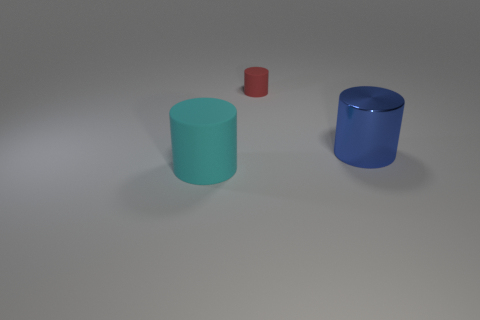What material is the cylinder right of the rubber cylinder behind the large object that is behind the large cyan thing?
Your answer should be compact. Metal. What number of purple matte cylinders are there?
Provide a succinct answer. 0. How many gray objects are big cylinders or tiny cylinders?
Offer a terse response. 0. How many other objects are there of the same shape as the blue metallic thing?
Give a very brief answer. 2. How many large objects are either blue cylinders or blue matte cubes?
Ensure brevity in your answer.  1. What is the size of the cyan matte thing that is the same shape as the blue shiny object?
Give a very brief answer. Large. Are there any other things that have the same size as the red matte object?
Offer a terse response. No. What is the large cylinder that is on the right side of the object behind the large metallic cylinder made of?
Offer a very short reply. Metal. What number of matte objects are big yellow spheres or small cylinders?
Your response must be concise. 1. There is another rubber object that is the same shape as the small red rubber thing; what is its color?
Make the answer very short. Cyan. 